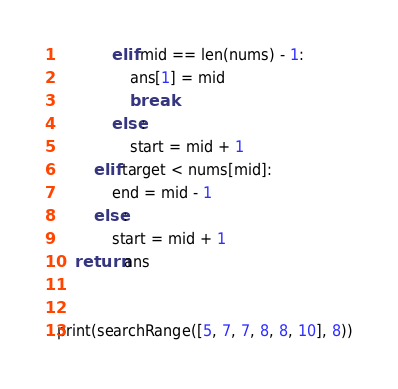Convert code to text. <code><loc_0><loc_0><loc_500><loc_500><_Python_>            elif mid == len(nums) - 1:
                ans[1] = mid
                break
            else:
                start = mid + 1
        elif target < nums[mid]:
            end = mid - 1
        else:
            start = mid + 1
    return ans


print(searchRange([5, 7, 7, 8, 8, 10], 8))</code> 